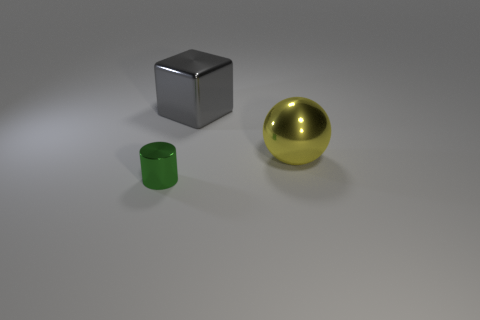How do the sizes of these objects compare to each other? In the image, the yellow ball is the largest object, approximately double the edge length of the cube if we infer that all are proportionate. The green cylindrical object is the smallest in terms of volume and height. These size relationships suggest a deliberate composition, possibly for a demonstration of scale, perspective, or an exercise in 3D rendering. 